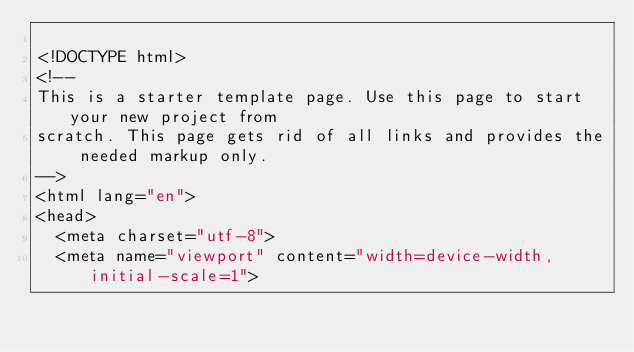Convert code to text. <code><loc_0><loc_0><loc_500><loc_500><_PHP_>
<!DOCTYPE html>
<!--
This is a starter template page. Use this page to start your new project from
scratch. This page gets rid of all links and provides the needed markup only.
-->
<html lang="en">
<head>
  <meta charset="utf-8">
  <meta name="viewport" content="width=device-width, initial-scale=1"></code> 